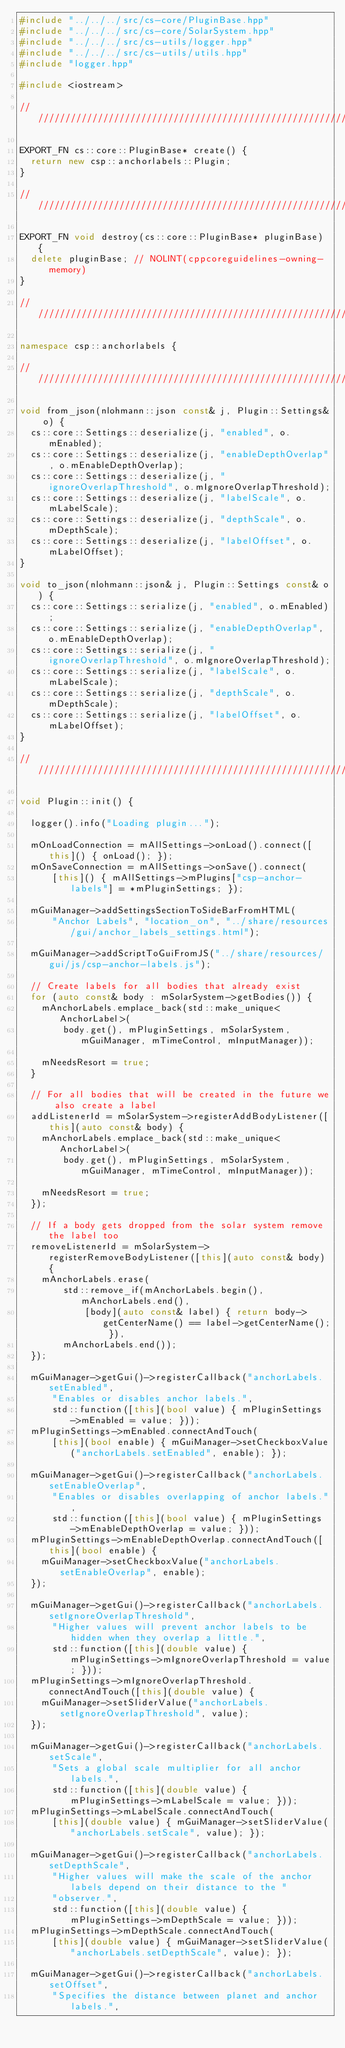<code> <loc_0><loc_0><loc_500><loc_500><_C++_>#include "../../../src/cs-core/PluginBase.hpp"
#include "../../../src/cs-core/SolarSystem.hpp"
#include "../../../src/cs-utils/logger.hpp"
#include "../../../src/cs-utils/utils.hpp"
#include "logger.hpp"

#include <iostream>

////////////////////////////////////////////////////////////////////////////////////////////////////

EXPORT_FN cs::core::PluginBase* create() {
  return new csp::anchorlabels::Plugin;
}

////////////////////////////////////////////////////////////////////////////////////////////////////

EXPORT_FN void destroy(cs::core::PluginBase* pluginBase) {
  delete pluginBase; // NOLINT(cppcoreguidelines-owning-memory)
}

////////////////////////////////////////////////////////////////////////////////////////////////////

namespace csp::anchorlabels {

////////////////////////////////////////////////////////////////////////////////////////////////////

void from_json(nlohmann::json const& j, Plugin::Settings& o) {
  cs::core::Settings::deserialize(j, "enabled", o.mEnabled);
  cs::core::Settings::deserialize(j, "enableDepthOverlap", o.mEnableDepthOverlap);
  cs::core::Settings::deserialize(j, "ignoreOverlapThreshold", o.mIgnoreOverlapThreshold);
  cs::core::Settings::deserialize(j, "labelScale", o.mLabelScale);
  cs::core::Settings::deserialize(j, "depthScale", o.mDepthScale);
  cs::core::Settings::deserialize(j, "labelOffset", o.mLabelOffset);
}

void to_json(nlohmann::json& j, Plugin::Settings const& o) {
  cs::core::Settings::serialize(j, "enabled", o.mEnabled);
  cs::core::Settings::serialize(j, "enableDepthOverlap", o.mEnableDepthOverlap);
  cs::core::Settings::serialize(j, "ignoreOverlapThreshold", o.mIgnoreOverlapThreshold);
  cs::core::Settings::serialize(j, "labelScale", o.mLabelScale);
  cs::core::Settings::serialize(j, "depthScale", o.mDepthScale);
  cs::core::Settings::serialize(j, "labelOffset", o.mLabelOffset);
}

////////////////////////////////////////////////////////////////////////////////////////////////////

void Plugin::init() {

  logger().info("Loading plugin...");

  mOnLoadConnection = mAllSettings->onLoad().connect([this]() { onLoad(); });
  mOnSaveConnection = mAllSettings->onSave().connect(
      [this]() { mAllSettings->mPlugins["csp-anchor-labels"] = *mPluginSettings; });

  mGuiManager->addSettingsSectionToSideBarFromHTML(
      "Anchor Labels", "location_on", "../share/resources/gui/anchor_labels_settings.html");

  mGuiManager->addScriptToGuiFromJS("../share/resources/gui/js/csp-anchor-labels.js");

  // Create labels for all bodies that already exist
  for (auto const& body : mSolarSystem->getBodies()) {
    mAnchorLabels.emplace_back(std::make_unique<AnchorLabel>(
        body.get(), mPluginSettings, mSolarSystem, mGuiManager, mTimeControl, mInputManager));

    mNeedsResort = true;
  }

  // For all bodies that will be created in the future we also create a label
  addListenerId = mSolarSystem->registerAddBodyListener([this](auto const& body) {
    mAnchorLabels.emplace_back(std::make_unique<AnchorLabel>(
        body.get(), mPluginSettings, mSolarSystem, mGuiManager, mTimeControl, mInputManager));

    mNeedsResort = true;
  });

  // If a body gets dropped from the solar system remove the label too
  removeListenerId = mSolarSystem->registerRemoveBodyListener([this](auto const& body) {
    mAnchorLabels.erase(
        std::remove_if(mAnchorLabels.begin(), mAnchorLabels.end(),
            [body](auto const& label) { return body->getCenterName() == label->getCenterName(); }),
        mAnchorLabels.end());
  });

  mGuiManager->getGui()->registerCallback("anchorLabels.setEnabled",
      "Enables or disables anchor labels.",
      std::function([this](bool value) { mPluginSettings->mEnabled = value; }));
  mPluginSettings->mEnabled.connectAndTouch(
      [this](bool enable) { mGuiManager->setCheckboxValue("anchorLabels.setEnabled", enable); });

  mGuiManager->getGui()->registerCallback("anchorLabels.setEnableOverlap",
      "Enables or disables overlapping of anchor labels.",
      std::function([this](bool value) { mPluginSettings->mEnableDepthOverlap = value; }));
  mPluginSettings->mEnableDepthOverlap.connectAndTouch([this](bool enable) {
    mGuiManager->setCheckboxValue("anchorLabels.setEnableOverlap", enable);
  });

  mGuiManager->getGui()->registerCallback("anchorLabels.setIgnoreOverlapThreshold",
      "Higher values will prevent anchor labels to be hidden when they overlap a little.",
      std::function([this](double value) { mPluginSettings->mIgnoreOverlapThreshold = value; }));
  mPluginSettings->mIgnoreOverlapThreshold.connectAndTouch([this](double value) {
    mGuiManager->setSliderValue("anchorLabels.setIgnoreOverlapThreshold", value);
  });

  mGuiManager->getGui()->registerCallback("anchorLabels.setScale",
      "Sets a global scale multiplier for all anchor labels.",
      std::function([this](double value) { mPluginSettings->mLabelScale = value; }));
  mPluginSettings->mLabelScale.connectAndTouch(
      [this](double value) { mGuiManager->setSliderValue("anchorLabels.setScale", value); });

  mGuiManager->getGui()->registerCallback("anchorLabels.setDepthScale",
      "Higher values will make the scale of the anchor labels depend on their distance to the "
      "observer.",
      std::function([this](double value) { mPluginSettings->mDepthScale = value; }));
  mPluginSettings->mDepthScale.connectAndTouch(
      [this](double value) { mGuiManager->setSliderValue("anchorLabels.setDepthScale", value); });

  mGuiManager->getGui()->registerCallback("anchorLabels.setOffset",
      "Specifies the distance between planet and anchor labels.",</code> 